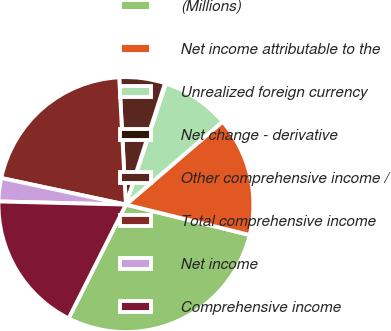Convert chart to OTSL. <chart><loc_0><loc_0><loc_500><loc_500><pie_chart><fcel>(Millions)<fcel>Net income attributable to the<fcel>Unrealized foreign currency<fcel>Net change - derivative<fcel>Other comprehensive income /<fcel>Total comprehensive income<fcel>Net income<fcel>Comprehensive income<nl><fcel>28.59%<fcel>15.12%<fcel>8.65%<fcel>0.1%<fcel>5.8%<fcel>20.82%<fcel>2.95%<fcel>17.97%<nl></chart> 